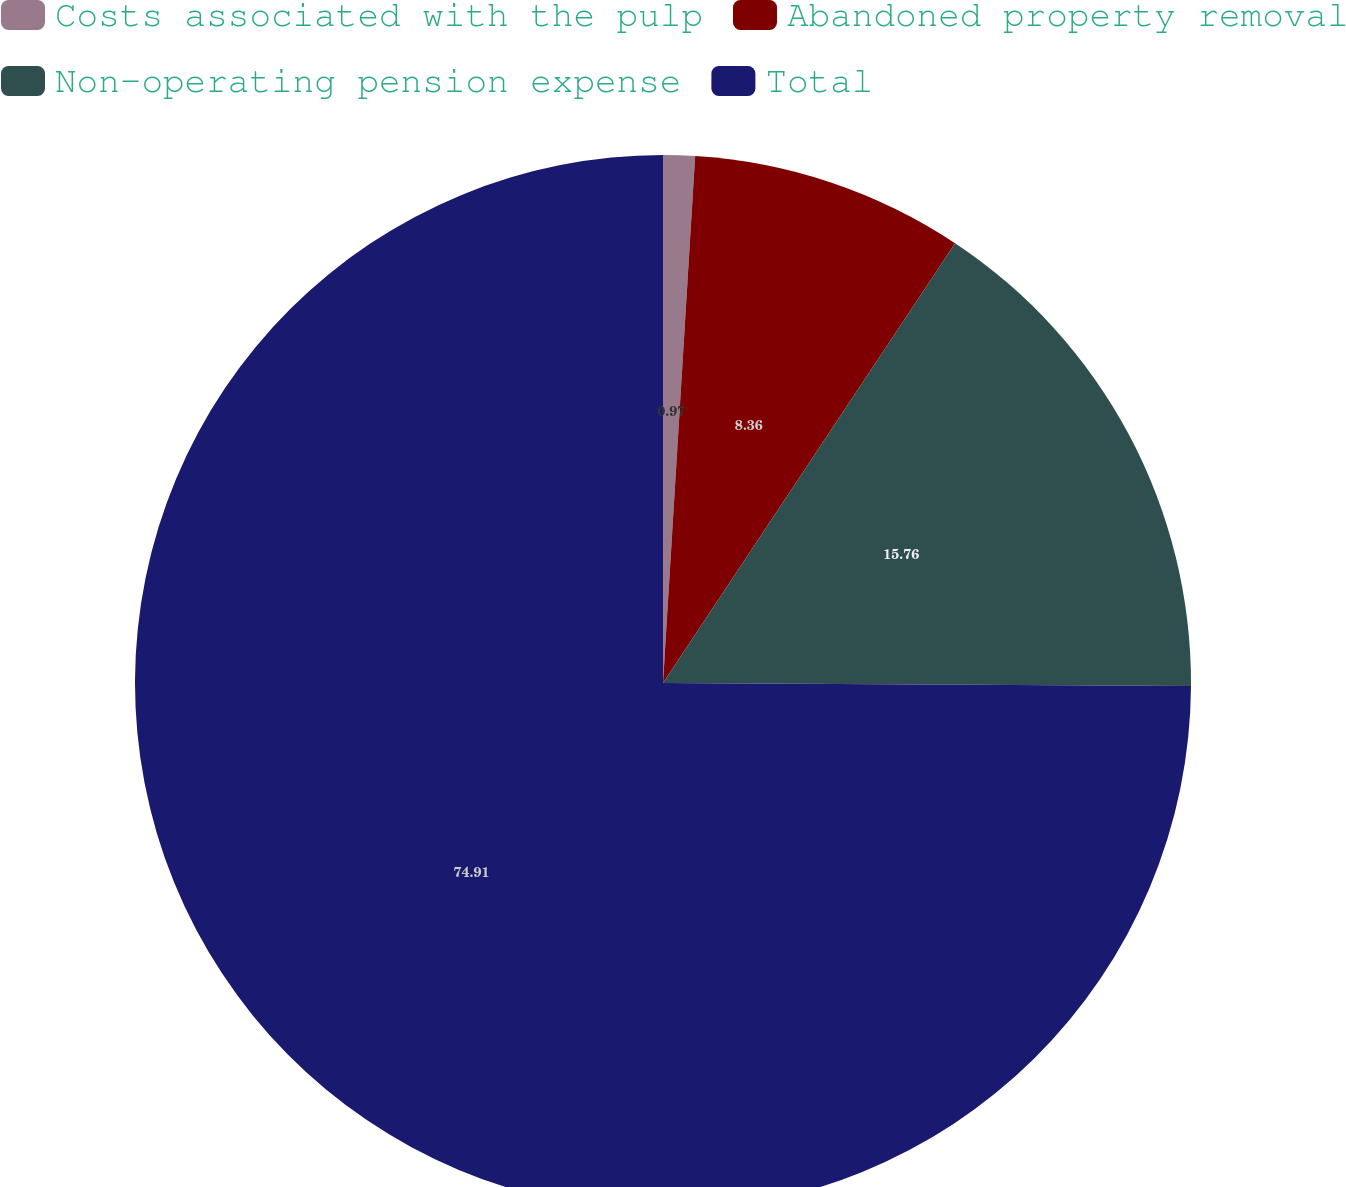Convert chart. <chart><loc_0><loc_0><loc_500><loc_500><pie_chart><fcel>Costs associated with the pulp<fcel>Abandoned property removal<fcel>Non-operating pension expense<fcel>Total<nl><fcel>0.97%<fcel>8.36%<fcel>15.76%<fcel>74.91%<nl></chart> 